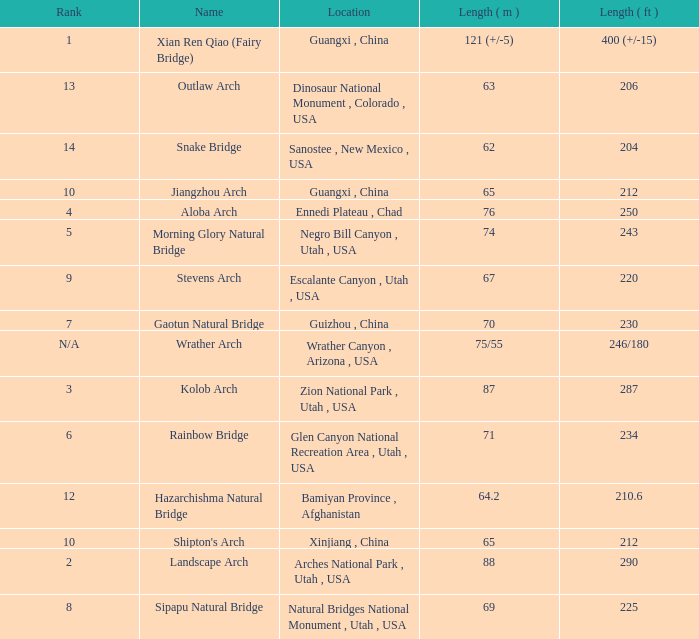Can you give me this table as a dict? {'header': ['Rank', 'Name', 'Location', 'Length ( m )', 'Length ( ft )'], 'rows': [['1', 'Xian Ren Qiao (Fairy Bridge)', 'Guangxi , China', '121 (+/-5)', '400 (+/-15)'], ['13', 'Outlaw Arch', 'Dinosaur National Monument , Colorado , USA', '63', '206'], ['14', 'Snake Bridge', 'Sanostee , New Mexico , USA', '62', '204'], ['10', 'Jiangzhou Arch', 'Guangxi , China', '65', '212'], ['4', 'Aloba Arch', 'Ennedi Plateau , Chad', '76', '250'], ['5', 'Morning Glory Natural Bridge', 'Negro Bill Canyon , Utah , USA', '74', '243'], ['9', 'Stevens Arch', 'Escalante Canyon , Utah , USA', '67', '220'], ['7', 'Gaotun Natural Bridge', 'Guizhou , China', '70', '230'], ['N/A', 'Wrather Arch', 'Wrather Canyon , Arizona , USA', '75/55', '246/180'], ['3', 'Kolob Arch', 'Zion National Park , Utah , USA', '87', '287'], ['6', 'Rainbow Bridge', 'Glen Canyon National Recreation Area , Utah , USA', '71', '234'], ['12', 'Hazarchishma Natural Bridge', 'Bamiyan Province , Afghanistan', '64.2', '210.6'], ['10', "Shipton's Arch", 'Xinjiang , China', '65', '212'], ['2', 'Landscape Arch', 'Arches National Park , Utah , USA', '88', '290'], ['8', 'Sipapu Natural Bridge', 'Natural Bridges National Monument , Utah , USA', '69', '225']]} What is the rank of the arch with a length in meters of 75/55? N/A. 